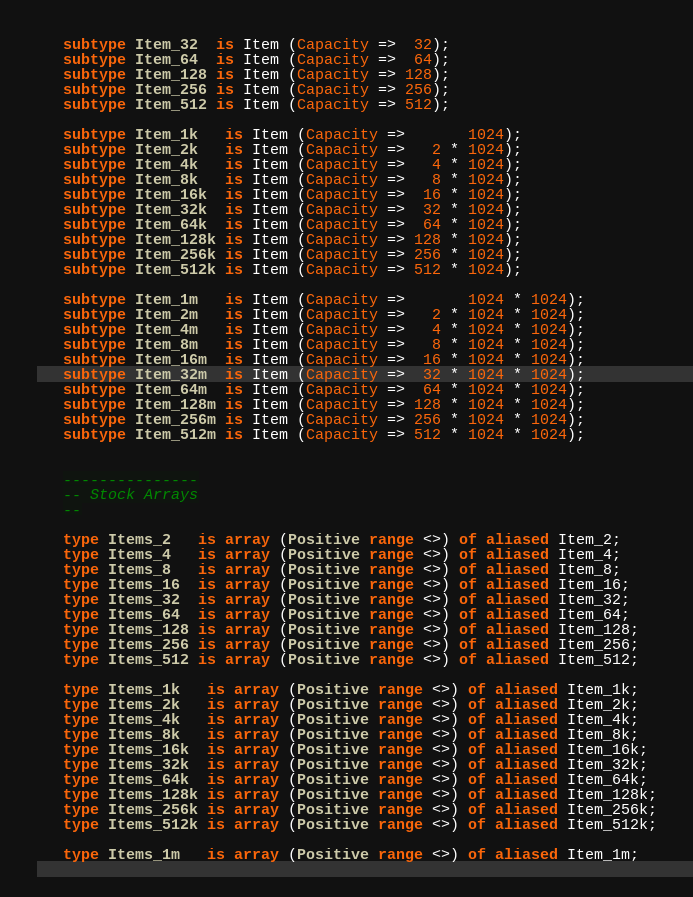<code> <loc_0><loc_0><loc_500><loc_500><_Ada_>   subtype Item_32  is Item (Capacity =>  32);
   subtype Item_64  is Item (Capacity =>  64);
   subtype Item_128 is Item (Capacity => 128);
   subtype Item_256 is Item (Capacity => 256);
   subtype Item_512 is Item (Capacity => 512);

   subtype Item_1k   is Item (Capacity =>       1024);
   subtype Item_2k   is Item (Capacity =>   2 * 1024);
   subtype Item_4k   is Item (Capacity =>   4 * 1024);
   subtype Item_8k   is Item (Capacity =>   8 * 1024);
   subtype Item_16k  is Item (Capacity =>  16 * 1024);
   subtype Item_32k  is Item (Capacity =>  32 * 1024);
   subtype Item_64k  is Item (Capacity =>  64 * 1024);
   subtype Item_128k is Item (Capacity => 128 * 1024);
   subtype Item_256k is Item (Capacity => 256 * 1024);
   subtype Item_512k is Item (Capacity => 512 * 1024);

   subtype Item_1m   is Item (Capacity =>       1024 * 1024);
   subtype Item_2m   is Item (Capacity =>   2 * 1024 * 1024);
   subtype Item_4m   is Item (Capacity =>   4 * 1024 * 1024);
   subtype Item_8m   is Item (Capacity =>   8 * 1024 * 1024);
   subtype Item_16m  is Item (Capacity =>  16 * 1024 * 1024);
   subtype Item_32m  is Item (Capacity =>  32 * 1024 * 1024);
   subtype Item_64m  is Item (Capacity =>  64 * 1024 * 1024);
   subtype Item_128m is Item (Capacity => 128 * 1024 * 1024);
   subtype Item_256m is Item (Capacity => 256 * 1024 * 1024);
   subtype Item_512m is Item (Capacity => 512 * 1024 * 1024);


   ---------------
   -- Stock Arrays
   --

   type Items_2   is array (Positive range <>) of aliased Item_2;
   type Items_4   is array (Positive range <>) of aliased Item_4;
   type Items_8   is array (Positive range <>) of aliased Item_8;
   type Items_16  is array (Positive range <>) of aliased Item_16;
   type Items_32  is array (Positive range <>) of aliased Item_32;
   type Items_64  is array (Positive range <>) of aliased Item_64;
   type Items_128 is array (Positive range <>) of aliased Item_128;
   type Items_256 is array (Positive range <>) of aliased Item_256;
   type Items_512 is array (Positive range <>) of aliased Item_512;

   type Items_1k   is array (Positive range <>) of aliased Item_1k;
   type Items_2k   is array (Positive range <>) of aliased Item_2k;
   type Items_4k   is array (Positive range <>) of aliased Item_4k;
   type Items_8k   is array (Positive range <>) of aliased Item_8k;
   type Items_16k  is array (Positive range <>) of aliased Item_16k;
   type Items_32k  is array (Positive range <>) of aliased Item_32k;
   type Items_64k  is array (Positive range <>) of aliased Item_64k;
   type Items_128k is array (Positive range <>) of aliased Item_128k;
   type Items_256k is array (Positive range <>) of aliased Item_256k;
   type Items_512k is array (Positive range <>) of aliased Item_512k;

   type Items_1m   is array (Positive range <>) of aliased Item_1m;</code> 